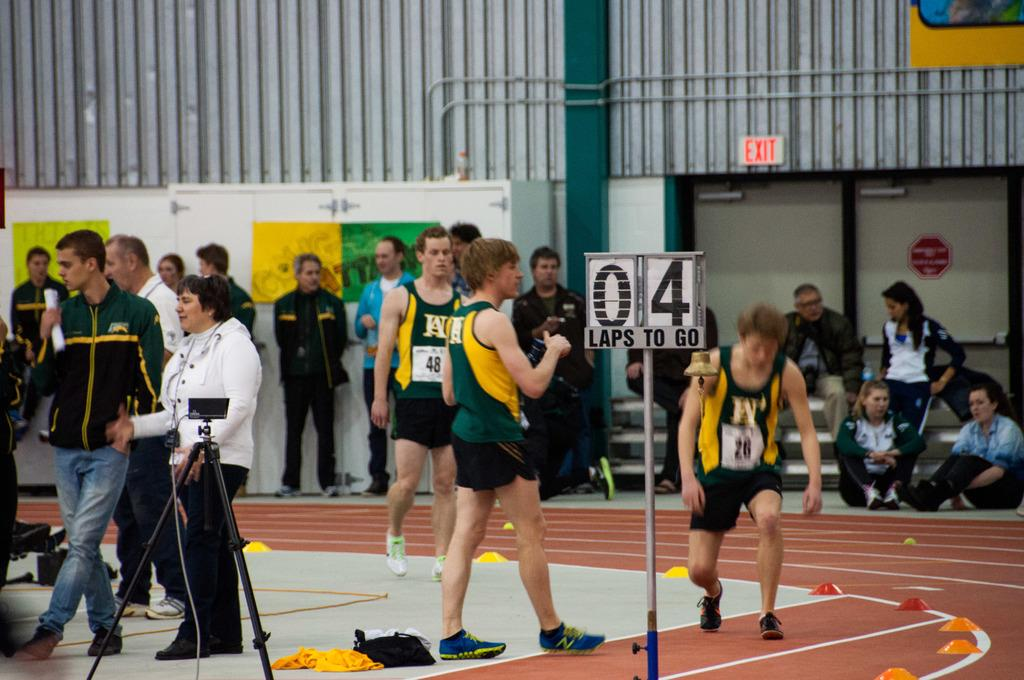<image>
Share a concise interpretation of the image provided. a runner with the number 4 next to him on a track 